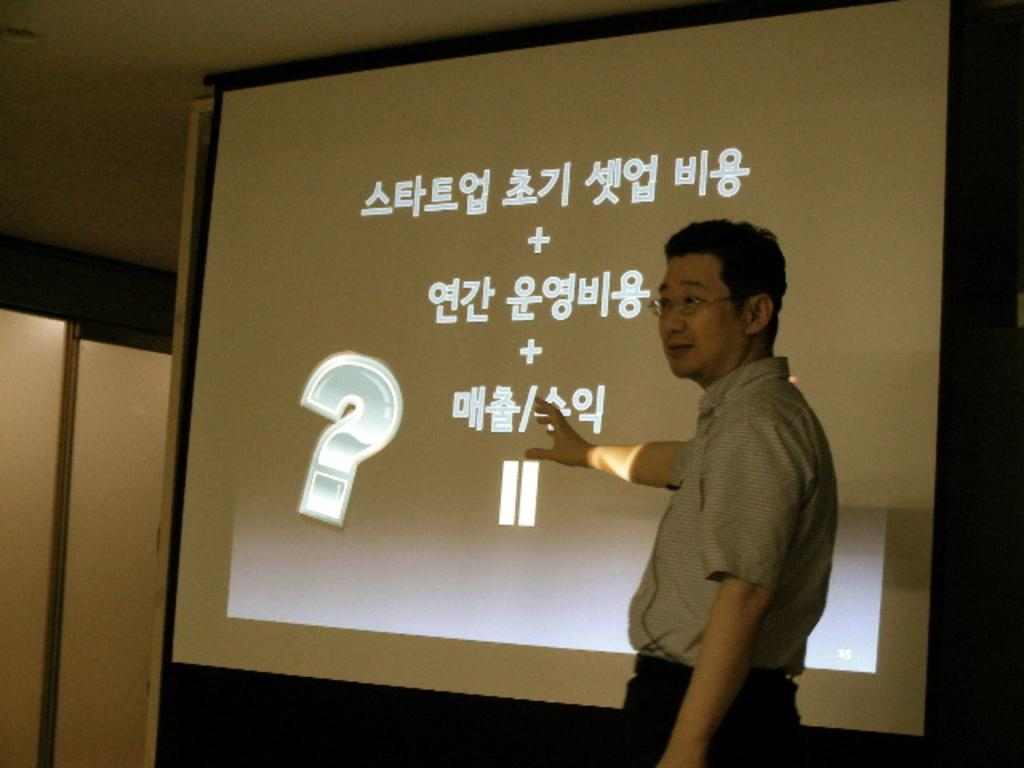Who is present in the image? There is a man in the image. What is the man wearing? The man is wearing a grey shirt and black pants. What is behind the man in the image? The man is standing in front of a screen. Where was the image taken? The image was taken inside a room. What type of fire can be seen in the image? There is no fire present in the image. How does the man express his hate in the image? There is no indication of hate or any negative emotion in the image; the man is simply standing in front of a screen. 